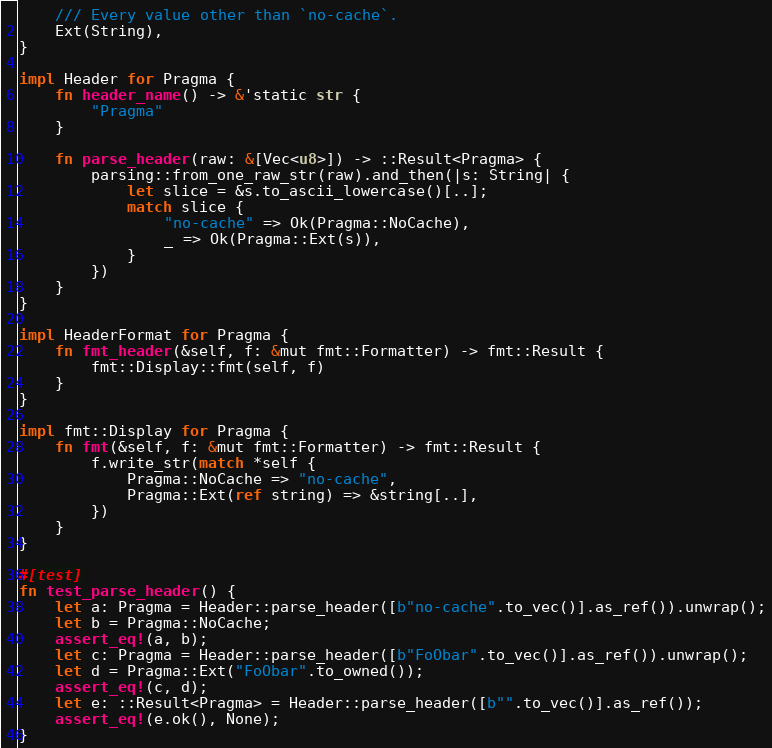Convert code to text. <code><loc_0><loc_0><loc_500><loc_500><_Rust_>    /// Every value other than `no-cache`.
    Ext(String),
}

impl Header for Pragma {
    fn header_name() -> &'static str {
        "Pragma"
    }

    fn parse_header(raw: &[Vec<u8>]) -> ::Result<Pragma> {
        parsing::from_one_raw_str(raw).and_then(|s: String| {
            let slice = &s.to_ascii_lowercase()[..];
            match slice {
                "no-cache" => Ok(Pragma::NoCache),
                _ => Ok(Pragma::Ext(s)),
            }
        })
    }
}

impl HeaderFormat for Pragma {
    fn fmt_header(&self, f: &mut fmt::Formatter) -> fmt::Result {
        fmt::Display::fmt(self, f)
    }
}

impl fmt::Display for Pragma {
    fn fmt(&self, f: &mut fmt::Formatter) -> fmt::Result {
        f.write_str(match *self {
            Pragma::NoCache => "no-cache",
            Pragma::Ext(ref string) => &string[..],
        })
    }
}

#[test]
fn test_parse_header() {
    let a: Pragma = Header::parse_header([b"no-cache".to_vec()].as_ref()).unwrap();
    let b = Pragma::NoCache;
    assert_eq!(a, b);
    let c: Pragma = Header::parse_header([b"FoObar".to_vec()].as_ref()).unwrap();
    let d = Pragma::Ext("FoObar".to_owned());
    assert_eq!(c, d);
    let e: ::Result<Pragma> = Header::parse_header([b"".to_vec()].as_ref());
    assert_eq!(e.ok(), None);
}
</code> 